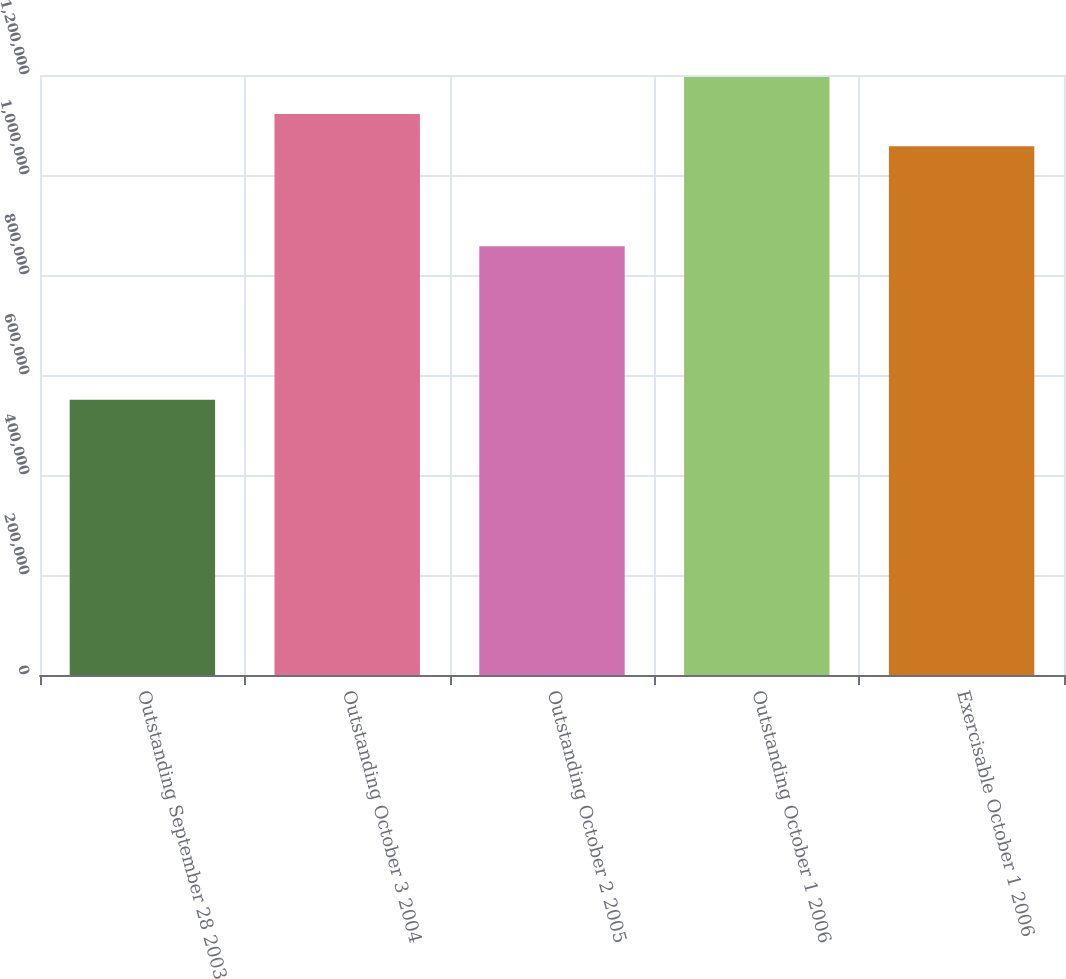Convert chart. <chart><loc_0><loc_0><loc_500><loc_500><bar_chart><fcel>Outstanding September 28 2003<fcel>Outstanding October 3 2004<fcel>Outstanding October 2 2005<fcel>Outstanding October 1 2006<fcel>Exercisable October 1 2006<nl><fcel>550420<fcel>1.12216e+06<fcel>857319<fcel>1.19621e+06<fcel>1.05758e+06<nl></chart> 